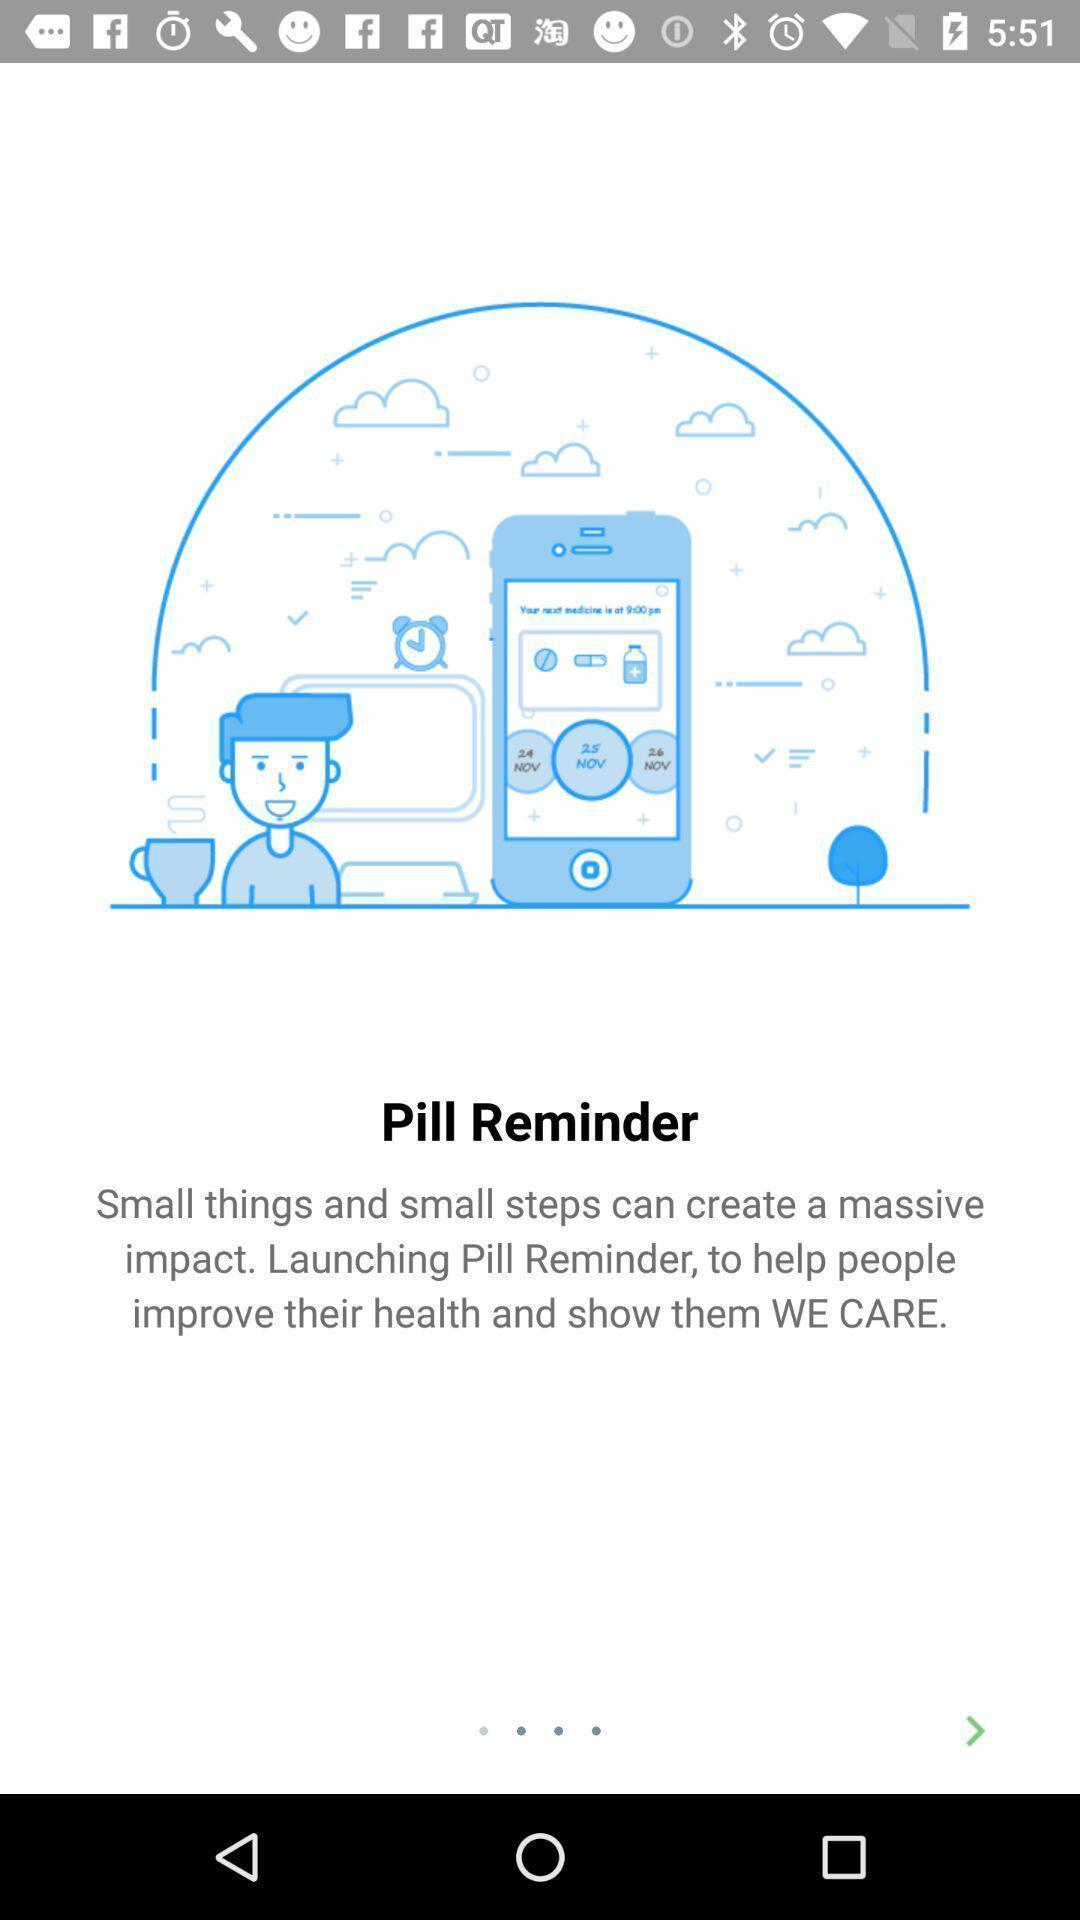Provide a textual representation of this image. Screen shows launch details of a health app. 